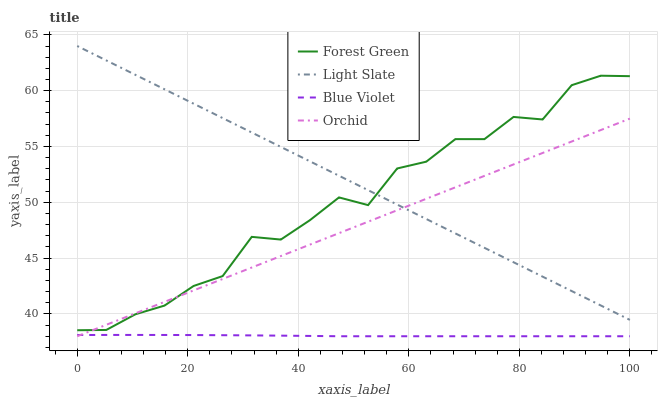Does Blue Violet have the minimum area under the curve?
Answer yes or no. Yes. Does Light Slate have the maximum area under the curve?
Answer yes or no. Yes. Does Forest Green have the minimum area under the curve?
Answer yes or no. No. Does Forest Green have the maximum area under the curve?
Answer yes or no. No. Is Light Slate the smoothest?
Answer yes or no. Yes. Is Forest Green the roughest?
Answer yes or no. Yes. Is Blue Violet the smoothest?
Answer yes or no. No. Is Blue Violet the roughest?
Answer yes or no. No. Does Blue Violet have the lowest value?
Answer yes or no. Yes. Does Forest Green have the lowest value?
Answer yes or no. No. Does Light Slate have the highest value?
Answer yes or no. Yes. Does Forest Green have the highest value?
Answer yes or no. No. Is Blue Violet less than Light Slate?
Answer yes or no. Yes. Is Forest Green greater than Blue Violet?
Answer yes or no. Yes. Does Light Slate intersect Forest Green?
Answer yes or no. Yes. Is Light Slate less than Forest Green?
Answer yes or no. No. Is Light Slate greater than Forest Green?
Answer yes or no. No. Does Blue Violet intersect Light Slate?
Answer yes or no. No. 